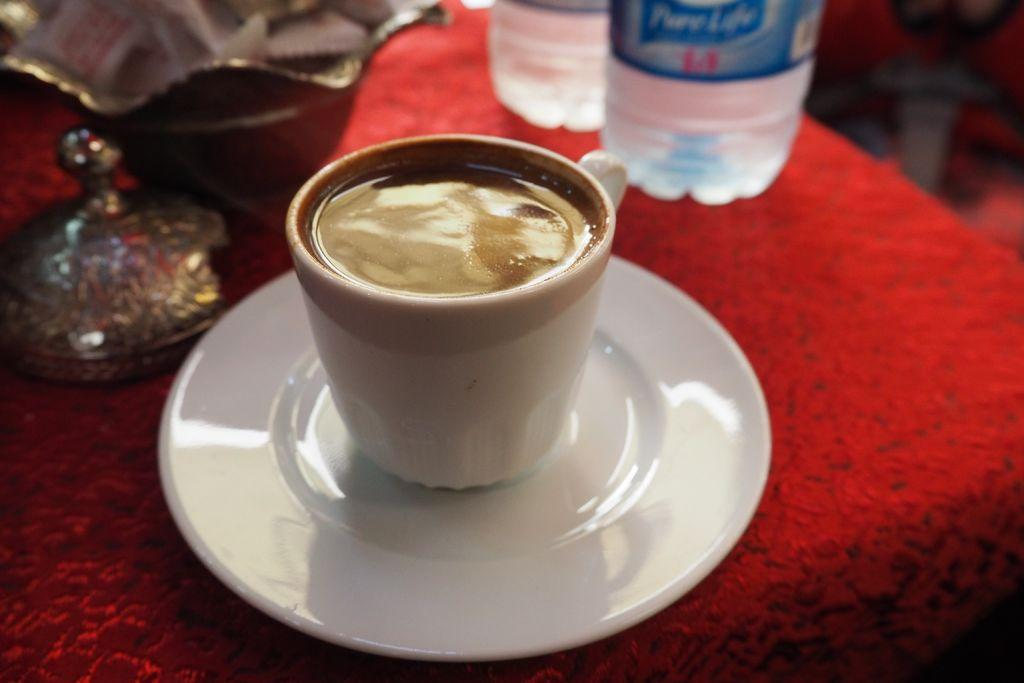What is in the cup that is visible in the image? There is a cup with coffee in the image. What is the cup resting on in the image? There is a saucer in the image. What other objects can be seen in the image? There is a bottle and a box visible in the image. What color is the cloth in the image? There is a red color cloth in the image. Where is the glove placed on the table in the image? There is no glove present in the image. What type of crayon can be seen in the image? There are no crayons present in the image. 